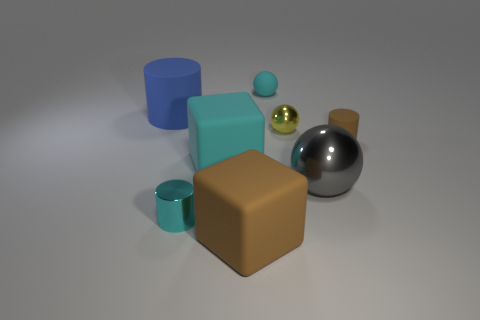There is a tiny ball behind the blue rubber object; is it the same color as the cube that is behind the gray sphere?
Your response must be concise. Yes. Is there a yellow metallic ball?
Provide a succinct answer. Yes. There is a big block that is the same color as the metallic cylinder; what material is it?
Offer a terse response. Rubber. What is the size of the cyan thing behind the brown rubber object right of the tiny rubber thing that is left of the tiny shiny ball?
Provide a short and direct response. Small. There is a big gray metallic object; does it have the same shape as the cyan object behind the large rubber cylinder?
Provide a succinct answer. Yes. Is there a large cylinder that has the same color as the small matte cylinder?
Ensure brevity in your answer.  No. What number of balls are brown objects or small metallic objects?
Give a very brief answer. 1. Is there another brown object that has the same shape as the big metal object?
Your answer should be very brief. No. How many other things are the same color as the large ball?
Offer a terse response. 0. Are there fewer yellow balls behind the yellow metallic object than small blue matte spheres?
Your response must be concise. No. 